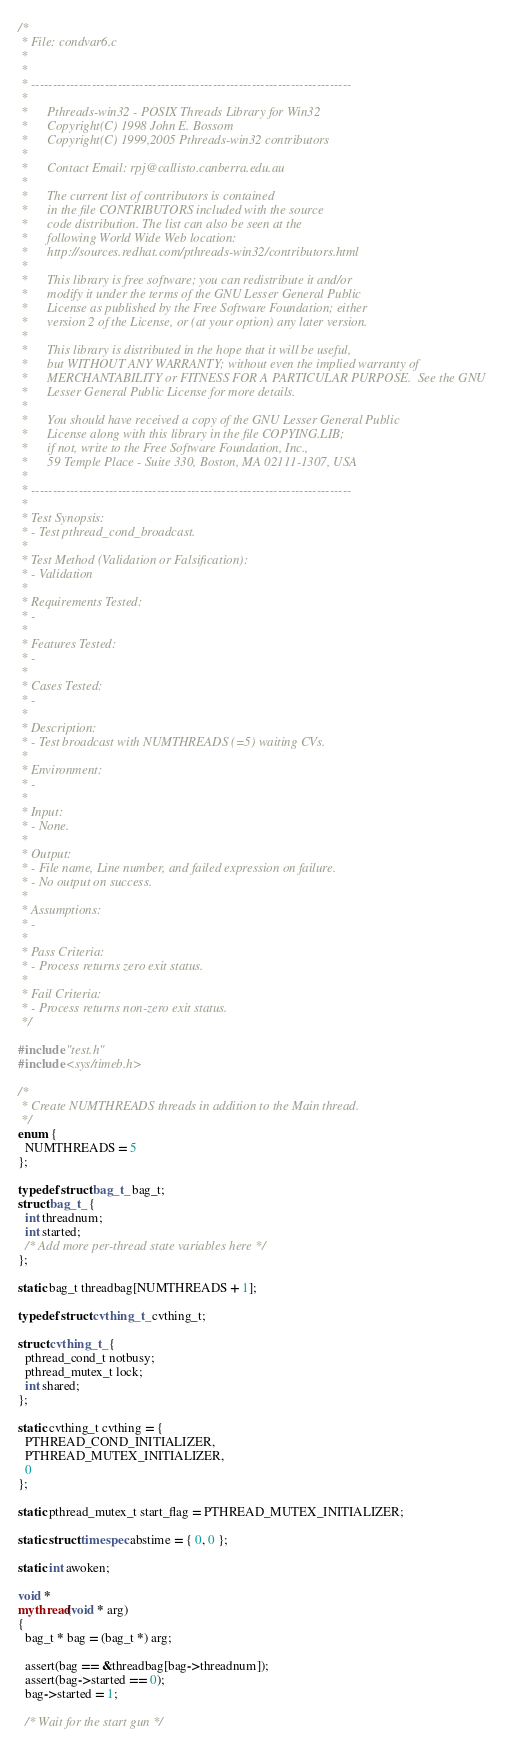Convert code to text. <code><loc_0><loc_0><loc_500><loc_500><_C_>/*
 * File: condvar6.c
 *
 *
 * --------------------------------------------------------------------------
 *
 *      Pthreads-win32 - POSIX Threads Library for Win32
 *      Copyright(C) 1998 John E. Bossom
 *      Copyright(C) 1999,2005 Pthreads-win32 contributors
 * 
 *      Contact Email: rpj@callisto.canberra.edu.au
 * 
 *      The current list of contributors is contained
 *      in the file CONTRIBUTORS included with the source
 *      code distribution. The list can also be seen at the
 *      following World Wide Web location:
 *      http://sources.redhat.com/pthreads-win32/contributors.html
 * 
 *      This library is free software; you can redistribute it and/or
 *      modify it under the terms of the GNU Lesser General Public
 *      License as published by the Free Software Foundation; either
 *      version 2 of the License, or (at your option) any later version.
 * 
 *      This library is distributed in the hope that it will be useful,
 *      but WITHOUT ANY WARRANTY; without even the implied warranty of
 *      MERCHANTABILITY or FITNESS FOR A PARTICULAR PURPOSE.  See the GNU
 *      Lesser General Public License for more details.
 * 
 *      You should have received a copy of the GNU Lesser General Public
 *      License along with this library in the file COPYING.LIB;
 *      if not, write to the Free Software Foundation, Inc.,
 *      59 Temple Place - Suite 330, Boston, MA 02111-1307, USA
 *
 * --------------------------------------------------------------------------
 *
 * Test Synopsis:
 * - Test pthread_cond_broadcast.
 *
 * Test Method (Validation or Falsification):
 * - Validation
 *
 * Requirements Tested:
 * - 
 *
 * Features Tested:
 * - 
 *
 * Cases Tested:
 * - 
 *
 * Description:
 * - Test broadcast with NUMTHREADS (=5) waiting CVs.
 *
 * Environment:
 * - 
 *
 * Input:
 * - None.
 *
 * Output:
 * - File name, Line number, and failed expression on failure.
 * - No output on success.
 *
 * Assumptions:
 * - 
 *
 * Pass Criteria:
 * - Process returns zero exit status.
 *
 * Fail Criteria:
 * - Process returns non-zero exit status.
 */

#include "test.h"
#include <sys/timeb.h>

/*
 * Create NUMTHREADS threads in addition to the Main thread.
 */
enum {
  NUMTHREADS = 5
};

typedef struct bag_t_ bag_t;
struct bag_t_ {
  int threadnum;
  int started;
  /* Add more per-thread state variables here */
};

static bag_t threadbag[NUMTHREADS + 1];

typedef struct cvthing_t_ cvthing_t;

struct cvthing_t_ {
  pthread_cond_t notbusy;
  pthread_mutex_t lock;
  int shared;
};

static cvthing_t cvthing = {
  PTHREAD_COND_INITIALIZER,
  PTHREAD_MUTEX_INITIALIZER,
  0
};

static pthread_mutex_t start_flag = PTHREAD_MUTEX_INITIALIZER;

static struct timespec abstime = { 0, 0 };

static int awoken;

void *
mythread(void * arg)
{
  bag_t * bag = (bag_t *) arg;

  assert(bag == &threadbag[bag->threadnum]);
  assert(bag->started == 0);
  bag->started = 1;

  /* Wait for the start gun */</code> 